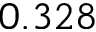<formula> <loc_0><loc_0><loc_500><loc_500>0 . 3 2 8</formula> 